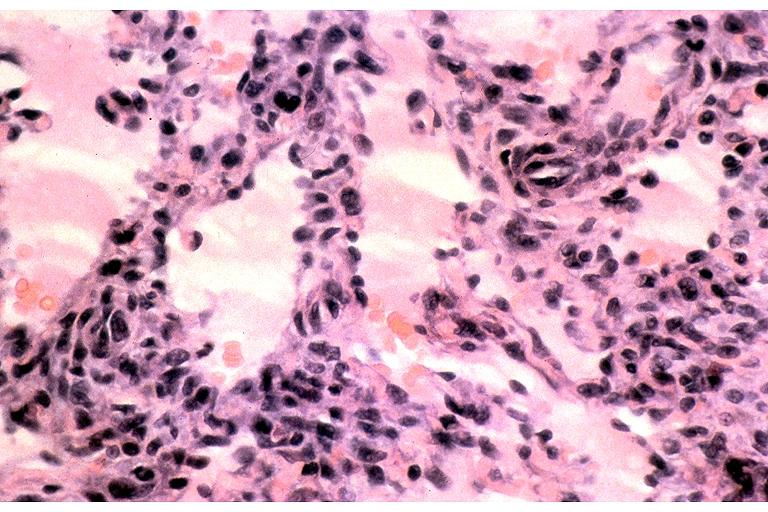where is this?
Answer the question using a single word or phrase. Oral 